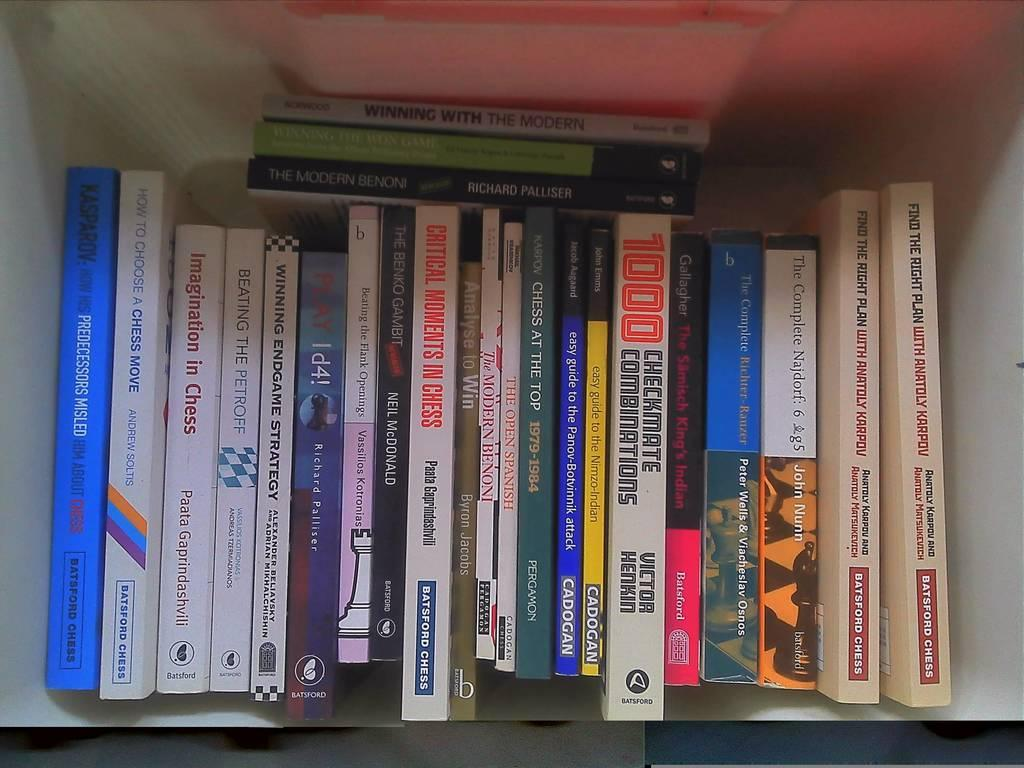<image>
Give a short and clear explanation of the subsequent image. The book "The Modern Benoni" sits on top of several other books on a white shelf. 